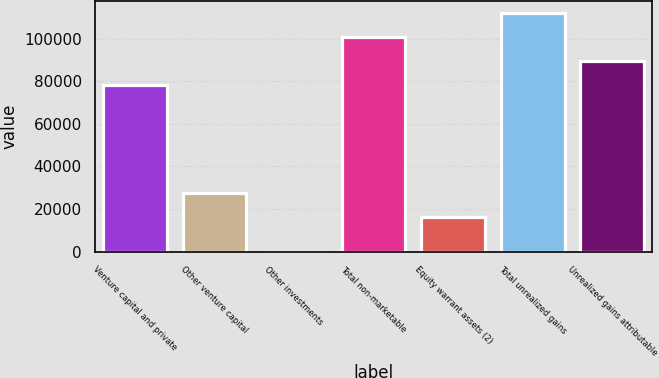<chart> <loc_0><loc_0><loc_500><loc_500><bar_chart><fcel>Venture capital and private<fcel>Other venture capital<fcel>Other investments<fcel>Total non-marketable<fcel>Equity warrant assets (2)<fcel>Total unrealized gains<fcel>Unrealized gains attributable<nl><fcel>78361<fcel>27556.2<fcel>24<fcel>100783<fcel>16345<fcel>112136<fcel>89572.2<nl></chart> 